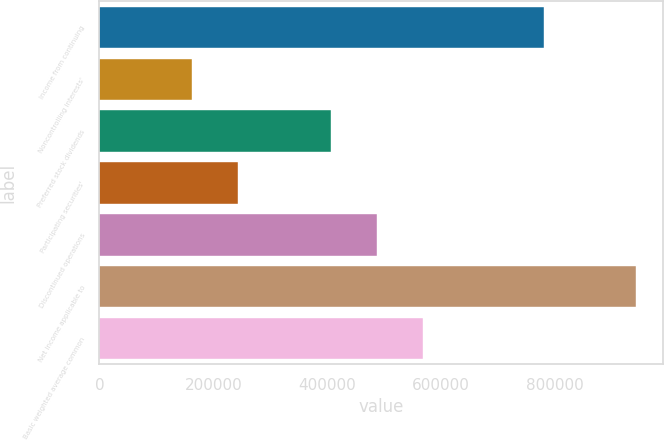Convert chart to OTSL. <chart><loc_0><loc_0><loc_500><loc_500><bar_chart><fcel>Income from continuing<fcel>Noncontrolling interests'<fcel>Preferred stock dividends<fcel>Participating securities'<fcel>Discontinued operations<fcel>Net income applicable to<fcel>Basic weighted average common<nl><fcel>780222<fcel>162578<fcel>406443<fcel>243867<fcel>487731<fcel>942798<fcel>569019<nl></chart> 